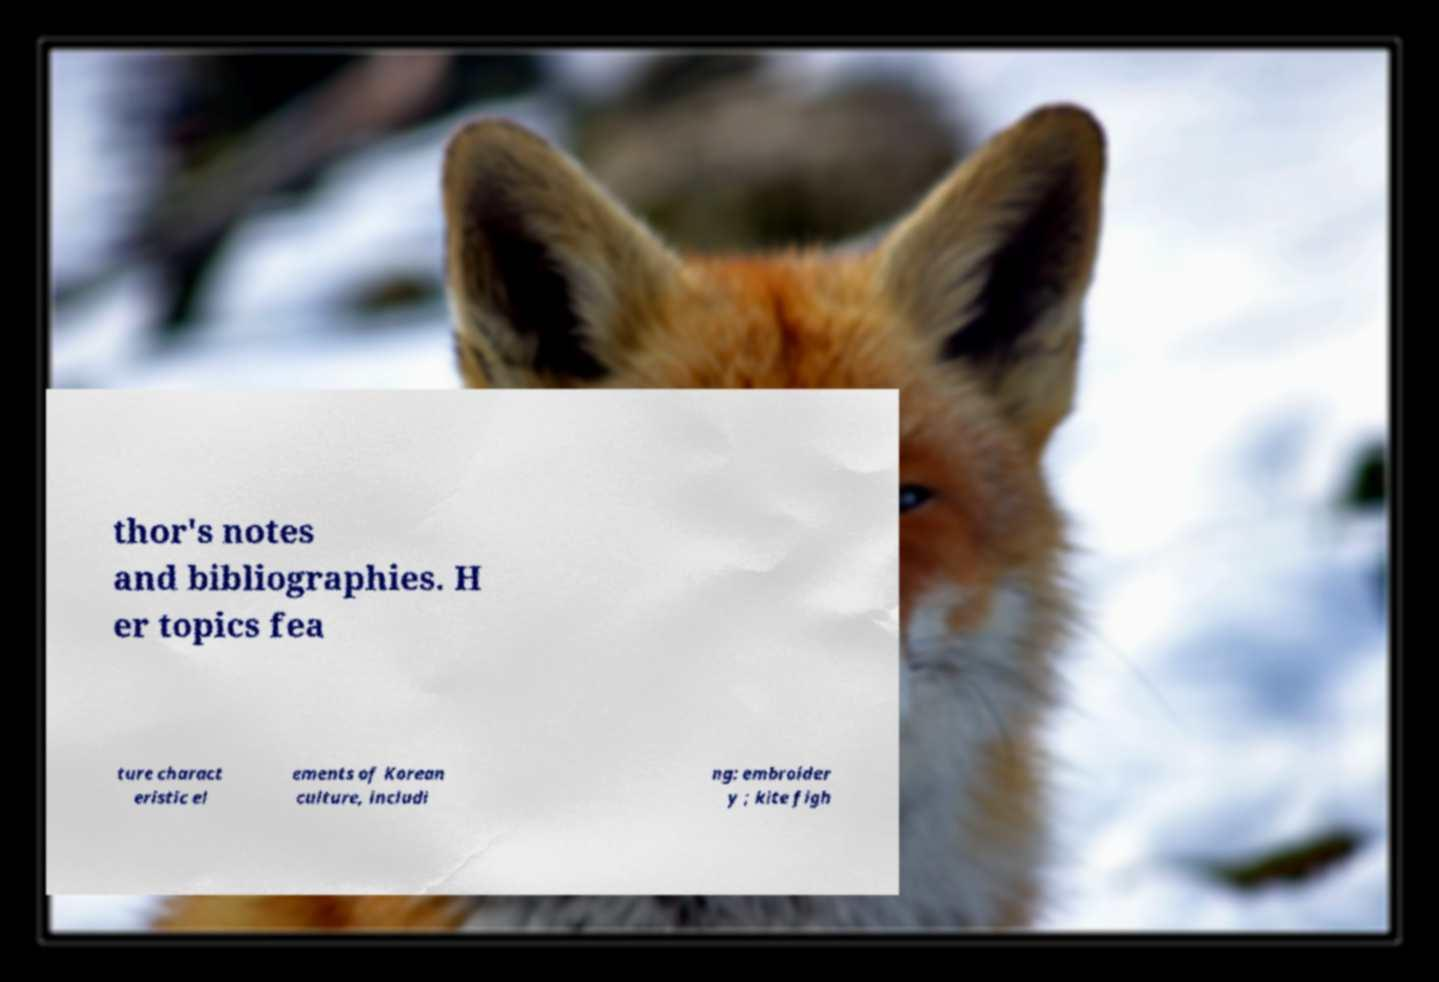What messages or text are displayed in this image? I need them in a readable, typed format. thor's notes and bibliographies. H er topics fea ture charact eristic el ements of Korean culture, includi ng: embroider y ; kite figh 